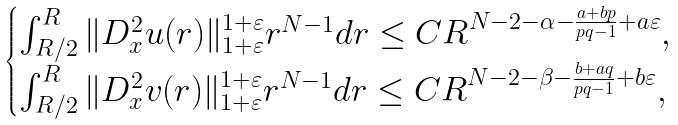<formula> <loc_0><loc_0><loc_500><loc_500>\begin{cases} \int _ { R / 2 } ^ { R } \| D _ { x } ^ { 2 } u ( r ) \| _ { 1 + \varepsilon } ^ { 1 + \varepsilon } r ^ { N - 1 } d r \leq C R ^ { N - 2 - \alpha - \frac { a + b p } { p q - 1 } + a \varepsilon } , \\ \int _ { R / 2 } ^ { R } \| D ^ { 2 } _ { x } v ( r ) \| _ { 1 + \varepsilon } ^ { 1 + \varepsilon } r ^ { N - 1 } d r \leq C R ^ { N - 2 - \beta - \frac { b + a q } { p q - 1 } + b \varepsilon } , \end{cases}</formula> 